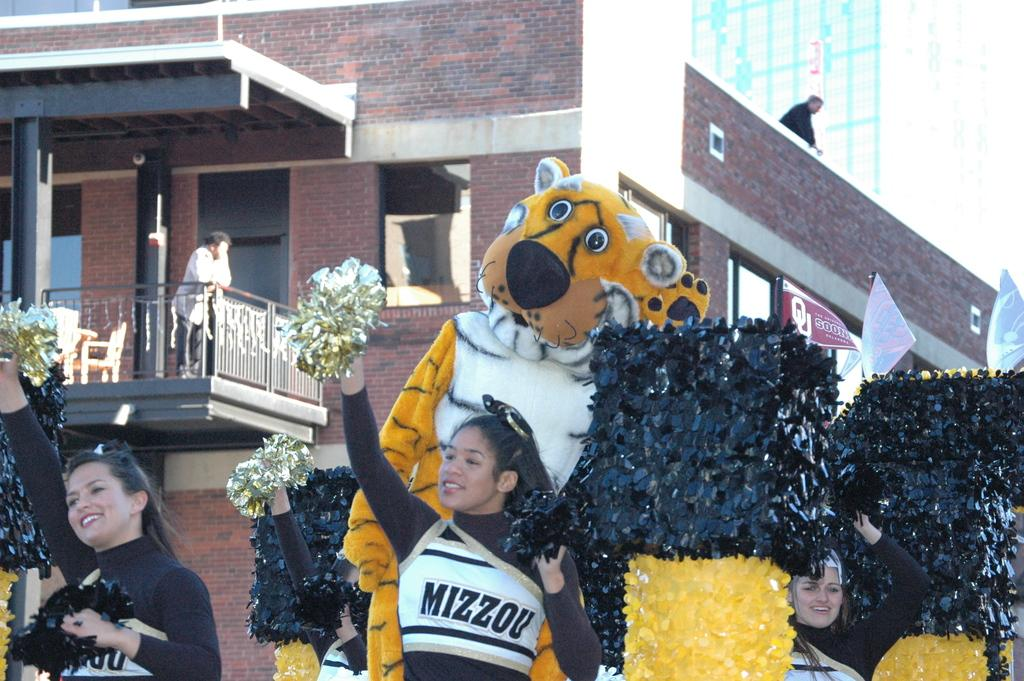Provide a one-sentence caption for the provided image. A cheerleader with Mizzou on her shirt stands in front of a tiger mascot. 